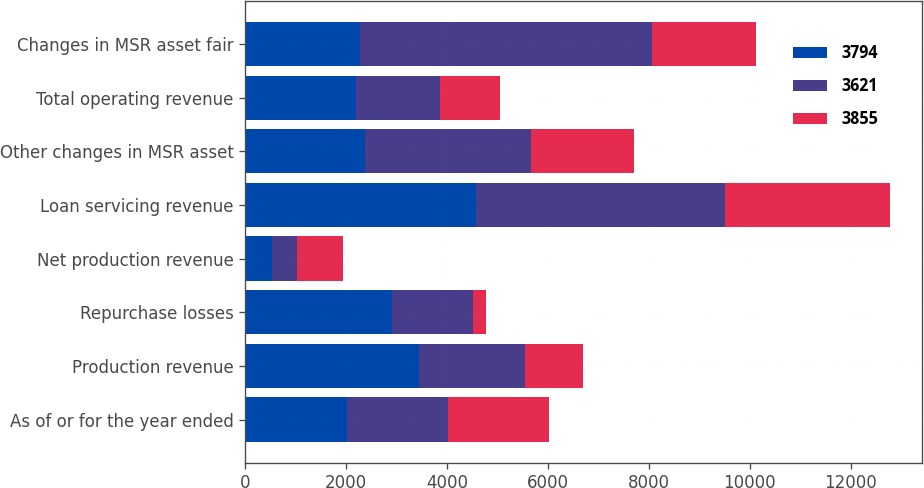Convert chart. <chart><loc_0><loc_0><loc_500><loc_500><stacked_bar_chart><ecel><fcel>As of or for the year ended<fcel>Production revenue<fcel>Repurchase losses<fcel>Net production revenue<fcel>Loan servicing revenue<fcel>Other changes in MSR asset<fcel>Total operating revenue<fcel>Changes in MSR asset fair<nl><fcel>3794<fcel>2010<fcel>3440<fcel>2912<fcel>528<fcel>4575<fcel>2384<fcel>2191<fcel>2268<nl><fcel>3621<fcel>2009<fcel>2115<fcel>1612<fcel>503<fcel>4942<fcel>3279<fcel>1663<fcel>5804<nl><fcel>3855<fcel>2008<fcel>1150<fcel>252<fcel>898<fcel>3258<fcel>2052<fcel>1206<fcel>2052<nl></chart> 